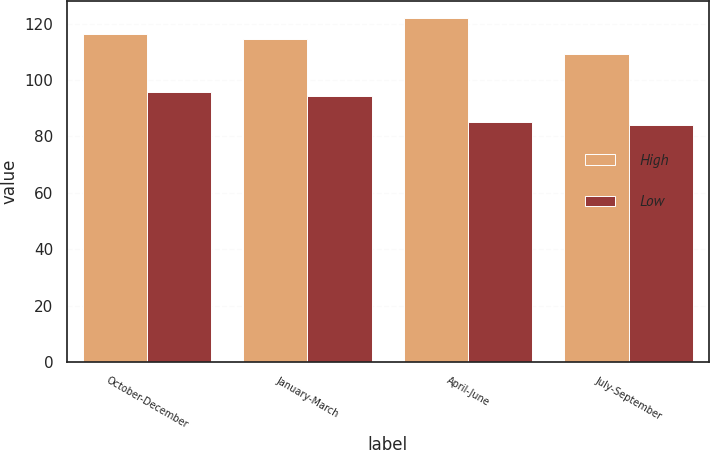Convert chart to OTSL. <chart><loc_0><loc_0><loc_500><loc_500><stacked_bar_chart><ecel><fcel>October-December<fcel>January-March<fcel>April-June<fcel>July-September<nl><fcel>High<fcel>116.38<fcel>114.71<fcel>121.89<fcel>109.19<nl><fcel>Low<fcel>95.86<fcel>94.43<fcel>85.2<fcel>84<nl></chart> 